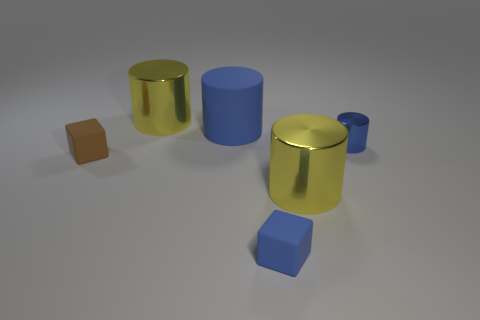Can you tell me about the composition of the objects within this image? Certainly! The composition features a variety of geometric shapes, both cylinders and cubes, arranged in a seemingly random pattern. The two yellow cylinders are prominent while the blue and brown shapes add contrast to the scene in terms of both color and size. 